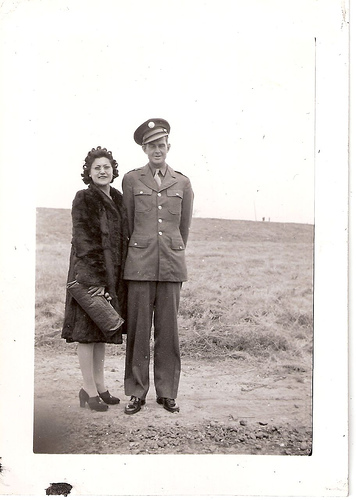<image>
Is there a man to the left of the woman? Yes. From this viewpoint, the man is positioned to the left side relative to the woman. 